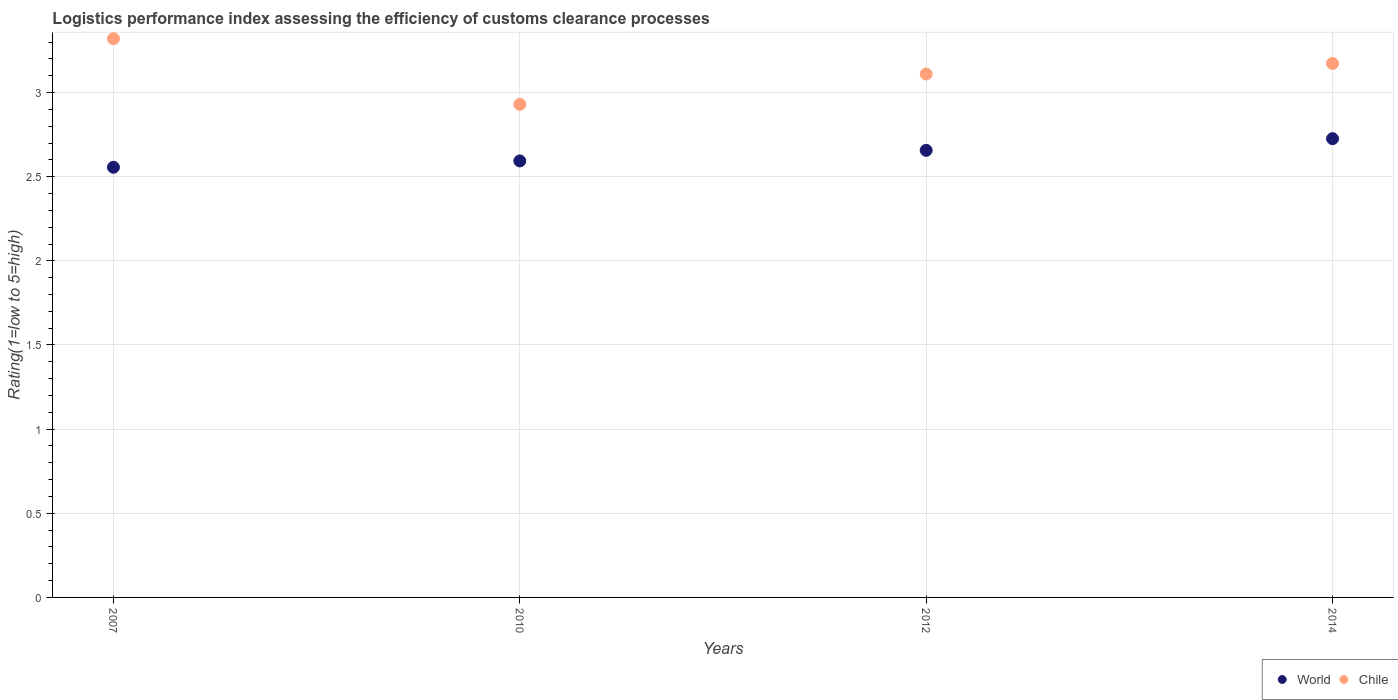How many different coloured dotlines are there?
Provide a short and direct response. 2. What is the Logistic performance index in Chile in 2014?
Ensure brevity in your answer.  3.17. Across all years, what is the maximum Logistic performance index in Chile?
Provide a succinct answer. 3.32. Across all years, what is the minimum Logistic performance index in World?
Your answer should be very brief. 2.56. In which year was the Logistic performance index in Chile maximum?
Your answer should be compact. 2007. In which year was the Logistic performance index in World minimum?
Give a very brief answer. 2007. What is the total Logistic performance index in World in the graph?
Offer a terse response. 10.53. What is the difference between the Logistic performance index in Chile in 2007 and that in 2014?
Give a very brief answer. 0.15. What is the difference between the Logistic performance index in World in 2007 and the Logistic performance index in Chile in 2010?
Your response must be concise. -0.37. What is the average Logistic performance index in World per year?
Provide a short and direct response. 2.63. In the year 2010, what is the difference between the Logistic performance index in World and Logistic performance index in Chile?
Provide a succinct answer. -0.34. What is the ratio of the Logistic performance index in Chile in 2010 to that in 2012?
Provide a short and direct response. 0.94. Is the Logistic performance index in Chile in 2010 less than that in 2012?
Offer a very short reply. Yes. Is the difference between the Logistic performance index in World in 2007 and 2014 greater than the difference between the Logistic performance index in Chile in 2007 and 2014?
Offer a very short reply. No. What is the difference between the highest and the second highest Logistic performance index in Chile?
Offer a terse response. 0.15. What is the difference between the highest and the lowest Logistic performance index in World?
Provide a short and direct response. 0.17. Is the Logistic performance index in Chile strictly less than the Logistic performance index in World over the years?
Offer a very short reply. No. How many years are there in the graph?
Make the answer very short. 4. What is the difference between two consecutive major ticks on the Y-axis?
Keep it short and to the point. 0.5. Are the values on the major ticks of Y-axis written in scientific E-notation?
Ensure brevity in your answer.  No. Does the graph contain any zero values?
Provide a succinct answer. No. Does the graph contain grids?
Keep it short and to the point. Yes. Where does the legend appear in the graph?
Keep it short and to the point. Bottom right. How many legend labels are there?
Provide a succinct answer. 2. How are the legend labels stacked?
Your answer should be compact. Horizontal. What is the title of the graph?
Make the answer very short. Logistics performance index assessing the efficiency of customs clearance processes. Does "Benin" appear as one of the legend labels in the graph?
Provide a short and direct response. No. What is the label or title of the X-axis?
Your answer should be compact. Years. What is the label or title of the Y-axis?
Give a very brief answer. Rating(1=low to 5=high). What is the Rating(1=low to 5=high) in World in 2007?
Your answer should be compact. 2.56. What is the Rating(1=low to 5=high) of Chile in 2007?
Provide a short and direct response. 3.32. What is the Rating(1=low to 5=high) of World in 2010?
Your response must be concise. 2.59. What is the Rating(1=low to 5=high) of Chile in 2010?
Offer a very short reply. 2.93. What is the Rating(1=low to 5=high) of World in 2012?
Your response must be concise. 2.66. What is the Rating(1=low to 5=high) in Chile in 2012?
Your answer should be compact. 3.11. What is the Rating(1=low to 5=high) of World in 2014?
Your answer should be very brief. 2.73. What is the Rating(1=low to 5=high) of Chile in 2014?
Provide a succinct answer. 3.17. Across all years, what is the maximum Rating(1=low to 5=high) of World?
Provide a succinct answer. 2.73. Across all years, what is the maximum Rating(1=low to 5=high) of Chile?
Your answer should be very brief. 3.32. Across all years, what is the minimum Rating(1=low to 5=high) in World?
Your response must be concise. 2.56. Across all years, what is the minimum Rating(1=low to 5=high) of Chile?
Your answer should be compact. 2.93. What is the total Rating(1=low to 5=high) in World in the graph?
Your answer should be compact. 10.53. What is the total Rating(1=low to 5=high) of Chile in the graph?
Your answer should be compact. 12.53. What is the difference between the Rating(1=low to 5=high) in World in 2007 and that in 2010?
Keep it short and to the point. -0.04. What is the difference between the Rating(1=low to 5=high) in Chile in 2007 and that in 2010?
Make the answer very short. 0.39. What is the difference between the Rating(1=low to 5=high) in World in 2007 and that in 2012?
Provide a short and direct response. -0.1. What is the difference between the Rating(1=low to 5=high) in Chile in 2007 and that in 2012?
Your answer should be very brief. 0.21. What is the difference between the Rating(1=low to 5=high) in World in 2007 and that in 2014?
Give a very brief answer. -0.17. What is the difference between the Rating(1=low to 5=high) in Chile in 2007 and that in 2014?
Give a very brief answer. 0.15. What is the difference between the Rating(1=low to 5=high) of World in 2010 and that in 2012?
Provide a short and direct response. -0.06. What is the difference between the Rating(1=low to 5=high) in Chile in 2010 and that in 2012?
Your response must be concise. -0.18. What is the difference between the Rating(1=low to 5=high) of World in 2010 and that in 2014?
Your answer should be compact. -0.13. What is the difference between the Rating(1=low to 5=high) in Chile in 2010 and that in 2014?
Make the answer very short. -0.24. What is the difference between the Rating(1=low to 5=high) in World in 2012 and that in 2014?
Give a very brief answer. -0.07. What is the difference between the Rating(1=low to 5=high) in Chile in 2012 and that in 2014?
Provide a short and direct response. -0.06. What is the difference between the Rating(1=low to 5=high) in World in 2007 and the Rating(1=low to 5=high) in Chile in 2010?
Ensure brevity in your answer.  -0.37. What is the difference between the Rating(1=low to 5=high) of World in 2007 and the Rating(1=low to 5=high) of Chile in 2012?
Keep it short and to the point. -0.55. What is the difference between the Rating(1=low to 5=high) of World in 2007 and the Rating(1=low to 5=high) of Chile in 2014?
Your response must be concise. -0.62. What is the difference between the Rating(1=low to 5=high) of World in 2010 and the Rating(1=low to 5=high) of Chile in 2012?
Your answer should be very brief. -0.52. What is the difference between the Rating(1=low to 5=high) of World in 2010 and the Rating(1=low to 5=high) of Chile in 2014?
Make the answer very short. -0.58. What is the difference between the Rating(1=low to 5=high) in World in 2012 and the Rating(1=low to 5=high) in Chile in 2014?
Make the answer very short. -0.52. What is the average Rating(1=low to 5=high) in World per year?
Make the answer very short. 2.63. What is the average Rating(1=low to 5=high) of Chile per year?
Keep it short and to the point. 3.13. In the year 2007, what is the difference between the Rating(1=low to 5=high) in World and Rating(1=low to 5=high) in Chile?
Make the answer very short. -0.76. In the year 2010, what is the difference between the Rating(1=low to 5=high) in World and Rating(1=low to 5=high) in Chile?
Give a very brief answer. -0.34. In the year 2012, what is the difference between the Rating(1=low to 5=high) in World and Rating(1=low to 5=high) in Chile?
Your response must be concise. -0.45. In the year 2014, what is the difference between the Rating(1=low to 5=high) in World and Rating(1=low to 5=high) in Chile?
Offer a very short reply. -0.45. What is the ratio of the Rating(1=low to 5=high) in World in 2007 to that in 2010?
Give a very brief answer. 0.99. What is the ratio of the Rating(1=low to 5=high) in Chile in 2007 to that in 2010?
Offer a very short reply. 1.13. What is the ratio of the Rating(1=low to 5=high) of World in 2007 to that in 2012?
Provide a short and direct response. 0.96. What is the ratio of the Rating(1=low to 5=high) of Chile in 2007 to that in 2012?
Keep it short and to the point. 1.07. What is the ratio of the Rating(1=low to 5=high) of World in 2007 to that in 2014?
Your answer should be very brief. 0.94. What is the ratio of the Rating(1=low to 5=high) in Chile in 2007 to that in 2014?
Give a very brief answer. 1.05. What is the ratio of the Rating(1=low to 5=high) in World in 2010 to that in 2012?
Make the answer very short. 0.98. What is the ratio of the Rating(1=low to 5=high) in Chile in 2010 to that in 2012?
Make the answer very short. 0.94. What is the ratio of the Rating(1=low to 5=high) of World in 2010 to that in 2014?
Make the answer very short. 0.95. What is the ratio of the Rating(1=low to 5=high) of Chile in 2010 to that in 2014?
Make the answer very short. 0.92. What is the ratio of the Rating(1=low to 5=high) of World in 2012 to that in 2014?
Offer a very short reply. 0.97. What is the ratio of the Rating(1=low to 5=high) of Chile in 2012 to that in 2014?
Your response must be concise. 0.98. What is the difference between the highest and the second highest Rating(1=low to 5=high) of World?
Provide a short and direct response. 0.07. What is the difference between the highest and the second highest Rating(1=low to 5=high) in Chile?
Provide a short and direct response. 0.15. What is the difference between the highest and the lowest Rating(1=low to 5=high) in World?
Your answer should be very brief. 0.17. What is the difference between the highest and the lowest Rating(1=low to 5=high) of Chile?
Your answer should be very brief. 0.39. 